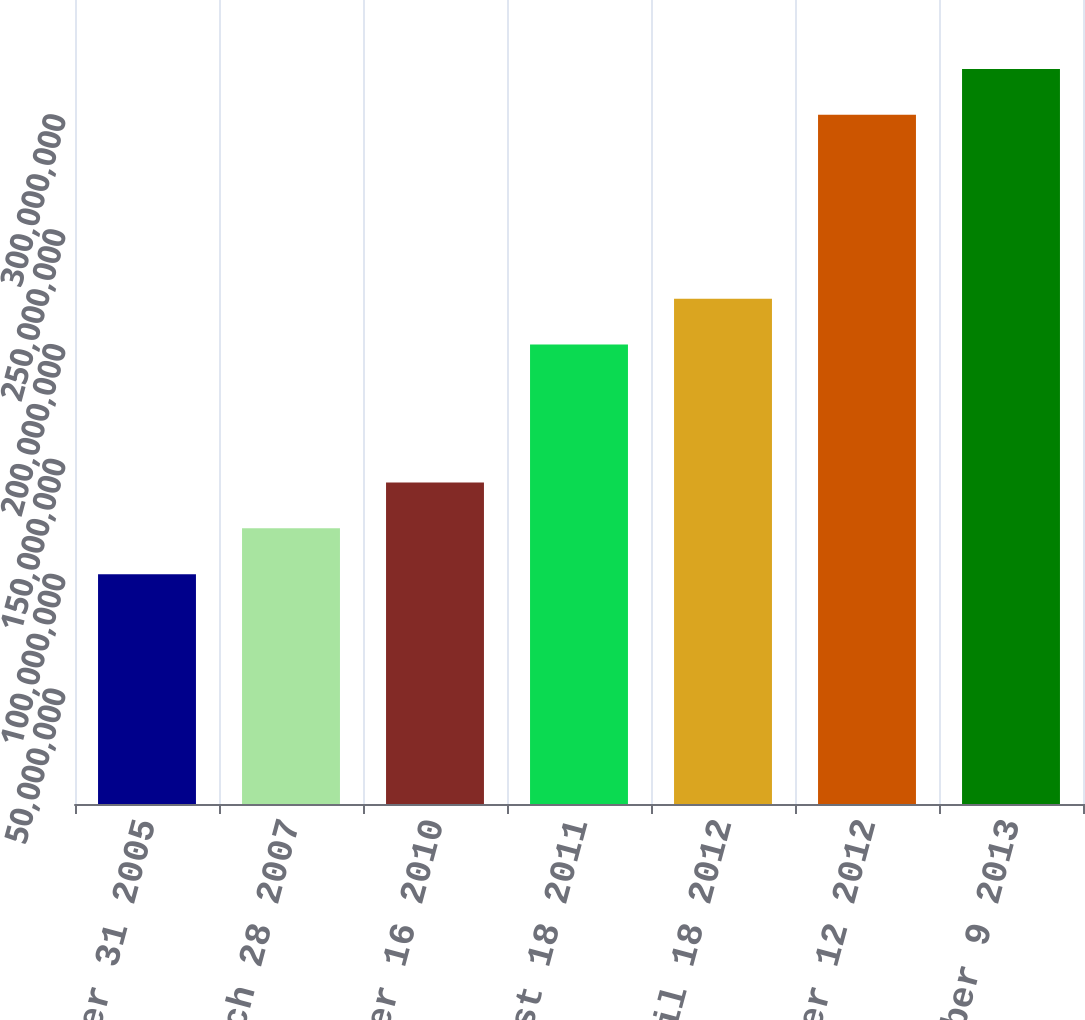Convert chart. <chart><loc_0><loc_0><loc_500><loc_500><bar_chart><fcel>October 31 2005<fcel>March 28 2007<fcel>November 16 2010<fcel>August 18 2011<fcel>April 18 2012<fcel>November 12 2012<fcel>December 9 2013<nl><fcel>1e+08<fcel>1.2e+08<fcel>1.4e+08<fcel>2e+08<fcel>2.2e+08<fcel>3e+08<fcel>3.2e+08<nl></chart> 